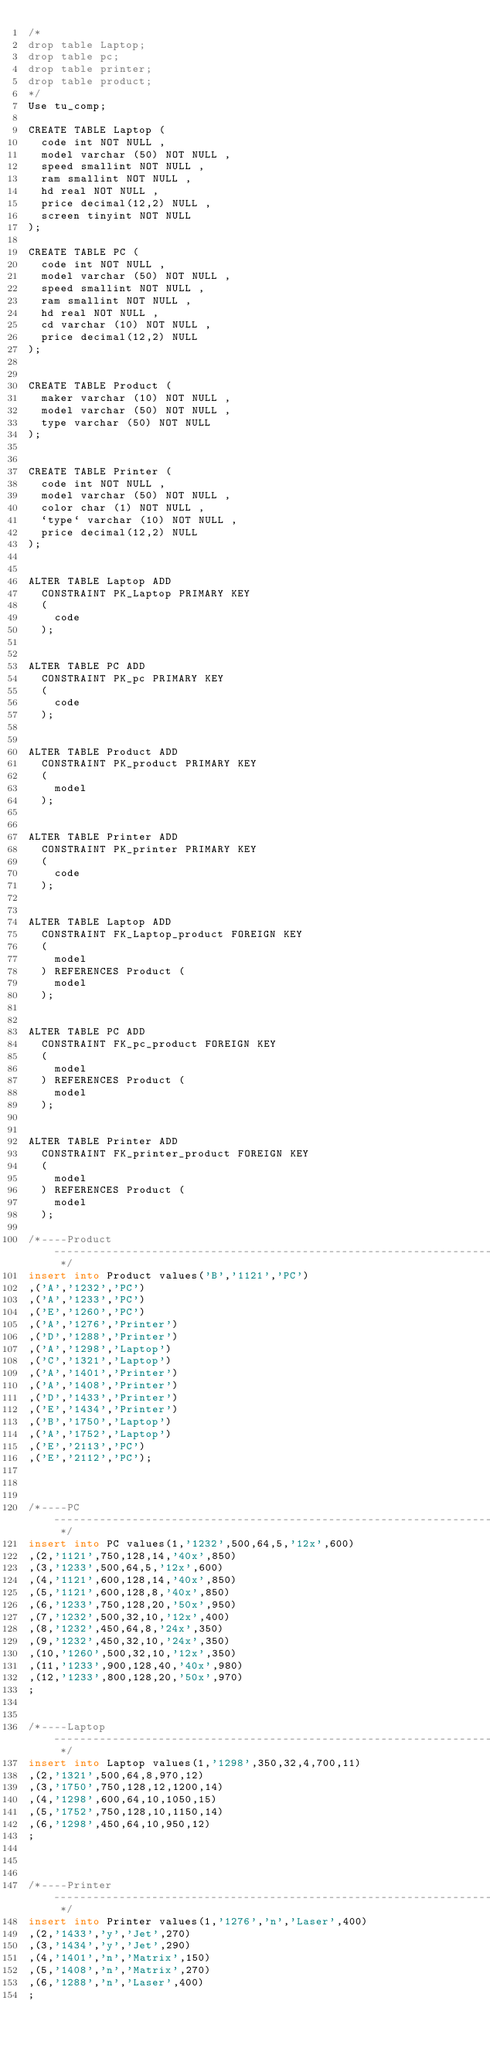<code> <loc_0><loc_0><loc_500><loc_500><_SQL_>/*
drop table Laptop;
drop table pc;
drop table printer;
drop table product;
*/
Use tu_comp;

CREATE TABLE Laptop (
	code int NOT NULL ,
	model varchar (50) NOT NULL ,
	speed smallint NOT NULL ,
	ram smallint NOT NULL ,
	hd real NOT NULL ,
	price decimal(12,2) NULL ,
	screen tinyint NOT NULL 
); 

CREATE TABLE PC (
	code int NOT NULL ,
	model varchar (50) NOT NULL ,
	speed smallint NOT NULL ,
	ram smallint NOT NULL ,
	hd real NOT NULL ,
	cd varchar (10) NOT NULL ,
	price decimal(12,2) NULL 
); 


CREATE TABLE Product (
	maker varchar (10) NOT NULL ,
	model varchar (50) NOT NULL ,
	type varchar (50) NOT NULL 
); 


CREATE TABLE Printer (
	code int NOT NULL ,
	model varchar (50) NOT NULL ,
	color char (1) NOT NULL ,
	`type` varchar (10) NOT NULL ,
	price decimal(12,2) NULL 
); 


ALTER TABLE Laptop ADD 
	CONSTRAINT PK_Laptop PRIMARY KEY 
	(
		code
	);   


ALTER TABLE PC ADD 
	CONSTRAINT PK_pc PRIMARY KEY 
	(
		code
	);   


ALTER TABLE Product ADD 
	CONSTRAINT PK_product PRIMARY KEY 
	(
		model
	);   


ALTER TABLE Printer ADD 
	CONSTRAINT PK_printer PRIMARY KEY 
	(
		code
	);   


ALTER TABLE Laptop ADD 
	CONSTRAINT FK_Laptop_product FOREIGN KEY 
	(
		model
	) REFERENCES Product (
		model
	);


ALTER TABLE PC ADD 
	CONSTRAINT FK_pc_product FOREIGN KEY 
	(
		model
	) REFERENCES Product (
		model
	);


ALTER TABLE Printer ADD 
	CONSTRAINT FK_printer_product FOREIGN KEY 
	(
		model
	) REFERENCES Product (
		model
	);

/*----Product------------------------------------------------------------------------------------------------------------------------------------------------------------------------------------------------------------------------------------------------------------ */
insert into Product values('B','1121','PC')
,('A','1232','PC')
,('A','1233','PC')
,('E','1260','PC')
,('A','1276','Printer')
,('D','1288','Printer')
,('A','1298','Laptop')
,('C','1321','Laptop')
,('A','1401','Printer')
,('A','1408','Printer')
,('D','1433','Printer')
,('E','1434','Printer')
,('B','1750','Laptop')
,('A','1752','Laptop')
,('E','2113','PC')
,('E','2112','PC');


                                                                                                                                                                                                                                                                 
/*----PC------------------------------------------------------------------------------------------------------------------------------------------------------------------------------------------------------------------------------------------------------------ */
insert into PC values(1,'1232',500,64,5,'12x',600)
,(2,'1121',750,128,14,'40x',850)
,(3,'1233',500,64,5,'12x',600)
,(4,'1121',600,128,14,'40x',850)
,(5,'1121',600,128,8,'40x',850)
,(6,'1233',750,128,20,'50x',950)
,(7,'1232',500,32,10,'12x',400)
,(8,'1232',450,64,8,'24x',350)
,(9,'1232',450,32,10,'24x',350)
,(10,'1260',500,32,10,'12x',350)
,(11,'1233',900,128,40,'40x',980)
,(12,'1233',800,128,20,'50x',970)
;

                                                                                                                                                                                                                                                                 
/*----Laptop------------------------------------------------------------------------------------------------------------------------------------------------------------------------------------------------------------------------------------------------------------ */
insert into Laptop values(1,'1298',350,32,4,700,11)
,(2,'1321',500,64,8,970,12)
,(3,'1750',750,128,12,1200,14)
,(4,'1298',600,64,10,1050,15)
,(5,'1752',750,128,10,1150,14)
,(6,'1298',450,64,10,950,12)
;


                                                                                                                                                                                                                                                                 
/*----Printer------------------------------------------------------------------------------------------------------------------------------------------------------------------------------------------------------------------------------------------------------------ */
insert into Printer values(1,'1276','n','Laser',400)
,(2,'1433','y','Jet',270)
,(3,'1434','y','Jet',290)
,(4,'1401','n','Matrix',150)
,(5,'1408','n','Matrix',270)
,(6,'1288','n','Laser',400)
;</code> 